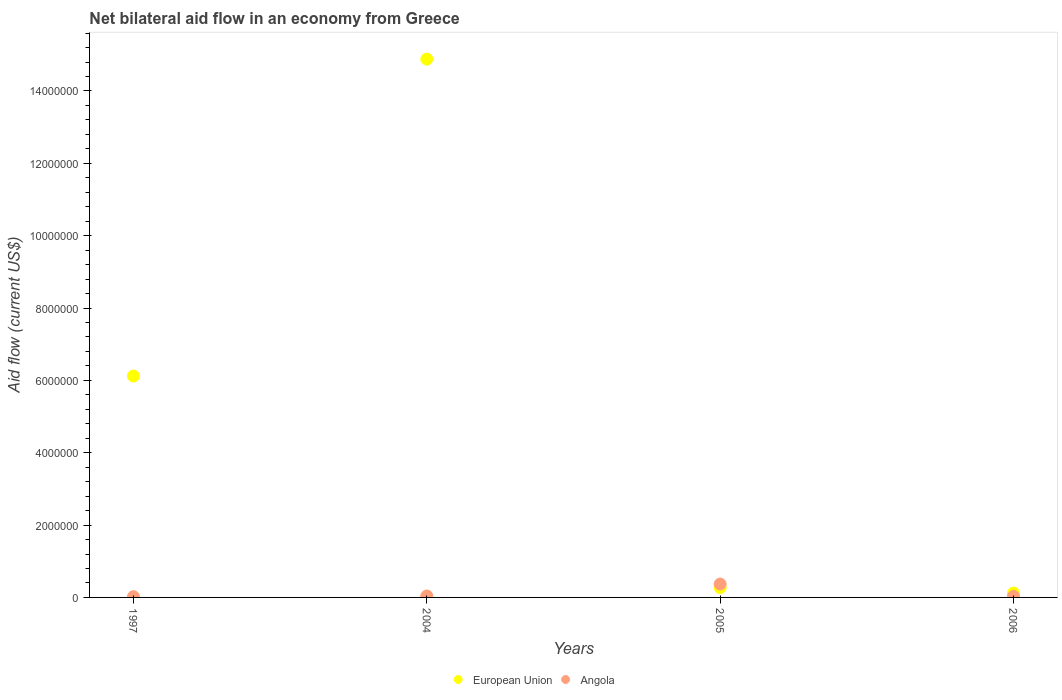How many different coloured dotlines are there?
Your response must be concise. 2. Across all years, what is the maximum net bilateral aid flow in European Union?
Give a very brief answer. 1.49e+07. In which year was the net bilateral aid flow in European Union minimum?
Offer a terse response. 2006. What is the difference between the net bilateral aid flow in European Union in 1997 and that in 2004?
Make the answer very short. -8.76e+06. What is the difference between the net bilateral aid flow in Angola in 1997 and the net bilateral aid flow in European Union in 2005?
Your answer should be compact. -2.50e+05. What is the average net bilateral aid flow in European Union per year?
Make the answer very short. 5.35e+06. In how many years, is the net bilateral aid flow in Angola greater than 5600000 US$?
Your response must be concise. 0. What is the ratio of the net bilateral aid flow in Angola in 2004 to that in 2006?
Your answer should be very brief. 1.33. Is the net bilateral aid flow in European Union in 2004 less than that in 2005?
Your response must be concise. No. What is the difference between the highest and the lowest net bilateral aid flow in Angola?
Provide a short and direct response. 3.50e+05. In how many years, is the net bilateral aid flow in Angola greater than the average net bilateral aid flow in Angola taken over all years?
Your answer should be very brief. 1. Is the sum of the net bilateral aid flow in European Union in 2004 and 2006 greater than the maximum net bilateral aid flow in Angola across all years?
Keep it short and to the point. Yes. Does the net bilateral aid flow in Angola monotonically increase over the years?
Keep it short and to the point. No. Is the net bilateral aid flow in Angola strictly greater than the net bilateral aid flow in European Union over the years?
Your response must be concise. No. Is the net bilateral aid flow in European Union strictly less than the net bilateral aid flow in Angola over the years?
Make the answer very short. No. How many dotlines are there?
Give a very brief answer. 2. How many years are there in the graph?
Your answer should be very brief. 4. What is the difference between two consecutive major ticks on the Y-axis?
Your response must be concise. 2.00e+06. Does the graph contain grids?
Keep it short and to the point. No. Where does the legend appear in the graph?
Make the answer very short. Bottom center. How are the legend labels stacked?
Keep it short and to the point. Horizontal. What is the title of the graph?
Make the answer very short. Net bilateral aid flow in an economy from Greece. Does "Mauritius" appear as one of the legend labels in the graph?
Your answer should be compact. No. What is the label or title of the Y-axis?
Provide a succinct answer. Aid flow (current US$). What is the Aid flow (current US$) in European Union in 1997?
Your answer should be very brief. 6.12e+06. What is the Aid flow (current US$) in Angola in 1997?
Provide a succinct answer. 2.00e+04. What is the Aid flow (current US$) of European Union in 2004?
Your response must be concise. 1.49e+07. What is the Aid flow (current US$) in Angola in 2004?
Your answer should be very brief. 4.00e+04. What is the Aid flow (current US$) in Angola in 2005?
Ensure brevity in your answer.  3.70e+05. What is the Aid flow (current US$) of Angola in 2006?
Keep it short and to the point. 3.00e+04. Across all years, what is the maximum Aid flow (current US$) of European Union?
Your answer should be compact. 1.49e+07. Across all years, what is the maximum Aid flow (current US$) in Angola?
Offer a terse response. 3.70e+05. Across all years, what is the minimum Aid flow (current US$) in European Union?
Offer a terse response. 1.20e+05. Across all years, what is the minimum Aid flow (current US$) of Angola?
Your response must be concise. 2.00e+04. What is the total Aid flow (current US$) of European Union in the graph?
Give a very brief answer. 2.14e+07. What is the total Aid flow (current US$) in Angola in the graph?
Keep it short and to the point. 4.60e+05. What is the difference between the Aid flow (current US$) of European Union in 1997 and that in 2004?
Your response must be concise. -8.76e+06. What is the difference between the Aid flow (current US$) of European Union in 1997 and that in 2005?
Ensure brevity in your answer.  5.85e+06. What is the difference between the Aid flow (current US$) of Angola in 1997 and that in 2005?
Your answer should be compact. -3.50e+05. What is the difference between the Aid flow (current US$) of European Union in 1997 and that in 2006?
Provide a succinct answer. 6.00e+06. What is the difference between the Aid flow (current US$) in European Union in 2004 and that in 2005?
Make the answer very short. 1.46e+07. What is the difference between the Aid flow (current US$) of Angola in 2004 and that in 2005?
Offer a very short reply. -3.30e+05. What is the difference between the Aid flow (current US$) of European Union in 2004 and that in 2006?
Ensure brevity in your answer.  1.48e+07. What is the difference between the Aid flow (current US$) of European Union in 1997 and the Aid flow (current US$) of Angola in 2004?
Give a very brief answer. 6.08e+06. What is the difference between the Aid flow (current US$) of European Union in 1997 and the Aid flow (current US$) of Angola in 2005?
Offer a very short reply. 5.75e+06. What is the difference between the Aid flow (current US$) of European Union in 1997 and the Aid flow (current US$) of Angola in 2006?
Your answer should be compact. 6.09e+06. What is the difference between the Aid flow (current US$) of European Union in 2004 and the Aid flow (current US$) of Angola in 2005?
Give a very brief answer. 1.45e+07. What is the difference between the Aid flow (current US$) of European Union in 2004 and the Aid flow (current US$) of Angola in 2006?
Ensure brevity in your answer.  1.48e+07. What is the difference between the Aid flow (current US$) in European Union in 2005 and the Aid flow (current US$) in Angola in 2006?
Offer a very short reply. 2.40e+05. What is the average Aid flow (current US$) in European Union per year?
Keep it short and to the point. 5.35e+06. What is the average Aid flow (current US$) of Angola per year?
Your answer should be very brief. 1.15e+05. In the year 1997, what is the difference between the Aid flow (current US$) of European Union and Aid flow (current US$) of Angola?
Your answer should be compact. 6.10e+06. In the year 2004, what is the difference between the Aid flow (current US$) in European Union and Aid flow (current US$) in Angola?
Keep it short and to the point. 1.48e+07. In the year 2006, what is the difference between the Aid flow (current US$) of European Union and Aid flow (current US$) of Angola?
Offer a terse response. 9.00e+04. What is the ratio of the Aid flow (current US$) of European Union in 1997 to that in 2004?
Make the answer very short. 0.41. What is the ratio of the Aid flow (current US$) in Angola in 1997 to that in 2004?
Ensure brevity in your answer.  0.5. What is the ratio of the Aid flow (current US$) in European Union in 1997 to that in 2005?
Keep it short and to the point. 22.67. What is the ratio of the Aid flow (current US$) of Angola in 1997 to that in 2005?
Ensure brevity in your answer.  0.05. What is the ratio of the Aid flow (current US$) in European Union in 2004 to that in 2005?
Give a very brief answer. 55.11. What is the ratio of the Aid flow (current US$) of Angola in 2004 to that in 2005?
Offer a terse response. 0.11. What is the ratio of the Aid flow (current US$) in European Union in 2004 to that in 2006?
Keep it short and to the point. 124. What is the ratio of the Aid flow (current US$) of European Union in 2005 to that in 2006?
Your response must be concise. 2.25. What is the ratio of the Aid flow (current US$) of Angola in 2005 to that in 2006?
Your response must be concise. 12.33. What is the difference between the highest and the second highest Aid flow (current US$) in European Union?
Ensure brevity in your answer.  8.76e+06. What is the difference between the highest and the lowest Aid flow (current US$) in European Union?
Provide a short and direct response. 1.48e+07. What is the difference between the highest and the lowest Aid flow (current US$) of Angola?
Make the answer very short. 3.50e+05. 